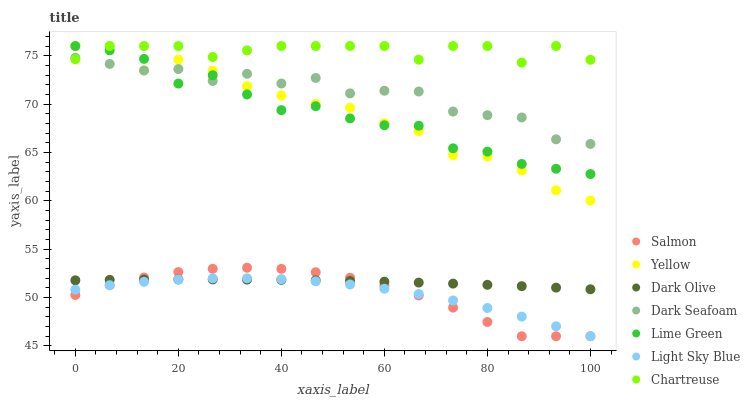Does Light Sky Blue have the minimum area under the curve?
Answer yes or no. Yes. Does Chartreuse have the maximum area under the curve?
Answer yes or no. Yes. Does Salmon have the minimum area under the curve?
Answer yes or no. No. Does Salmon have the maximum area under the curve?
Answer yes or no. No. Is Dark Olive the smoothest?
Answer yes or no. Yes. Is Lime Green the roughest?
Answer yes or no. Yes. Is Salmon the smoothest?
Answer yes or no. No. Is Salmon the roughest?
Answer yes or no. No. Does Salmon have the lowest value?
Answer yes or no. Yes. Does Chartreuse have the lowest value?
Answer yes or no. No. Does Lime Green have the highest value?
Answer yes or no. Yes. Does Salmon have the highest value?
Answer yes or no. No. Is Salmon less than Lime Green?
Answer yes or no. Yes. Is Dark Seafoam greater than Light Sky Blue?
Answer yes or no. Yes. Does Light Sky Blue intersect Dark Olive?
Answer yes or no. Yes. Is Light Sky Blue less than Dark Olive?
Answer yes or no. No. Is Light Sky Blue greater than Dark Olive?
Answer yes or no. No. Does Salmon intersect Lime Green?
Answer yes or no. No. 